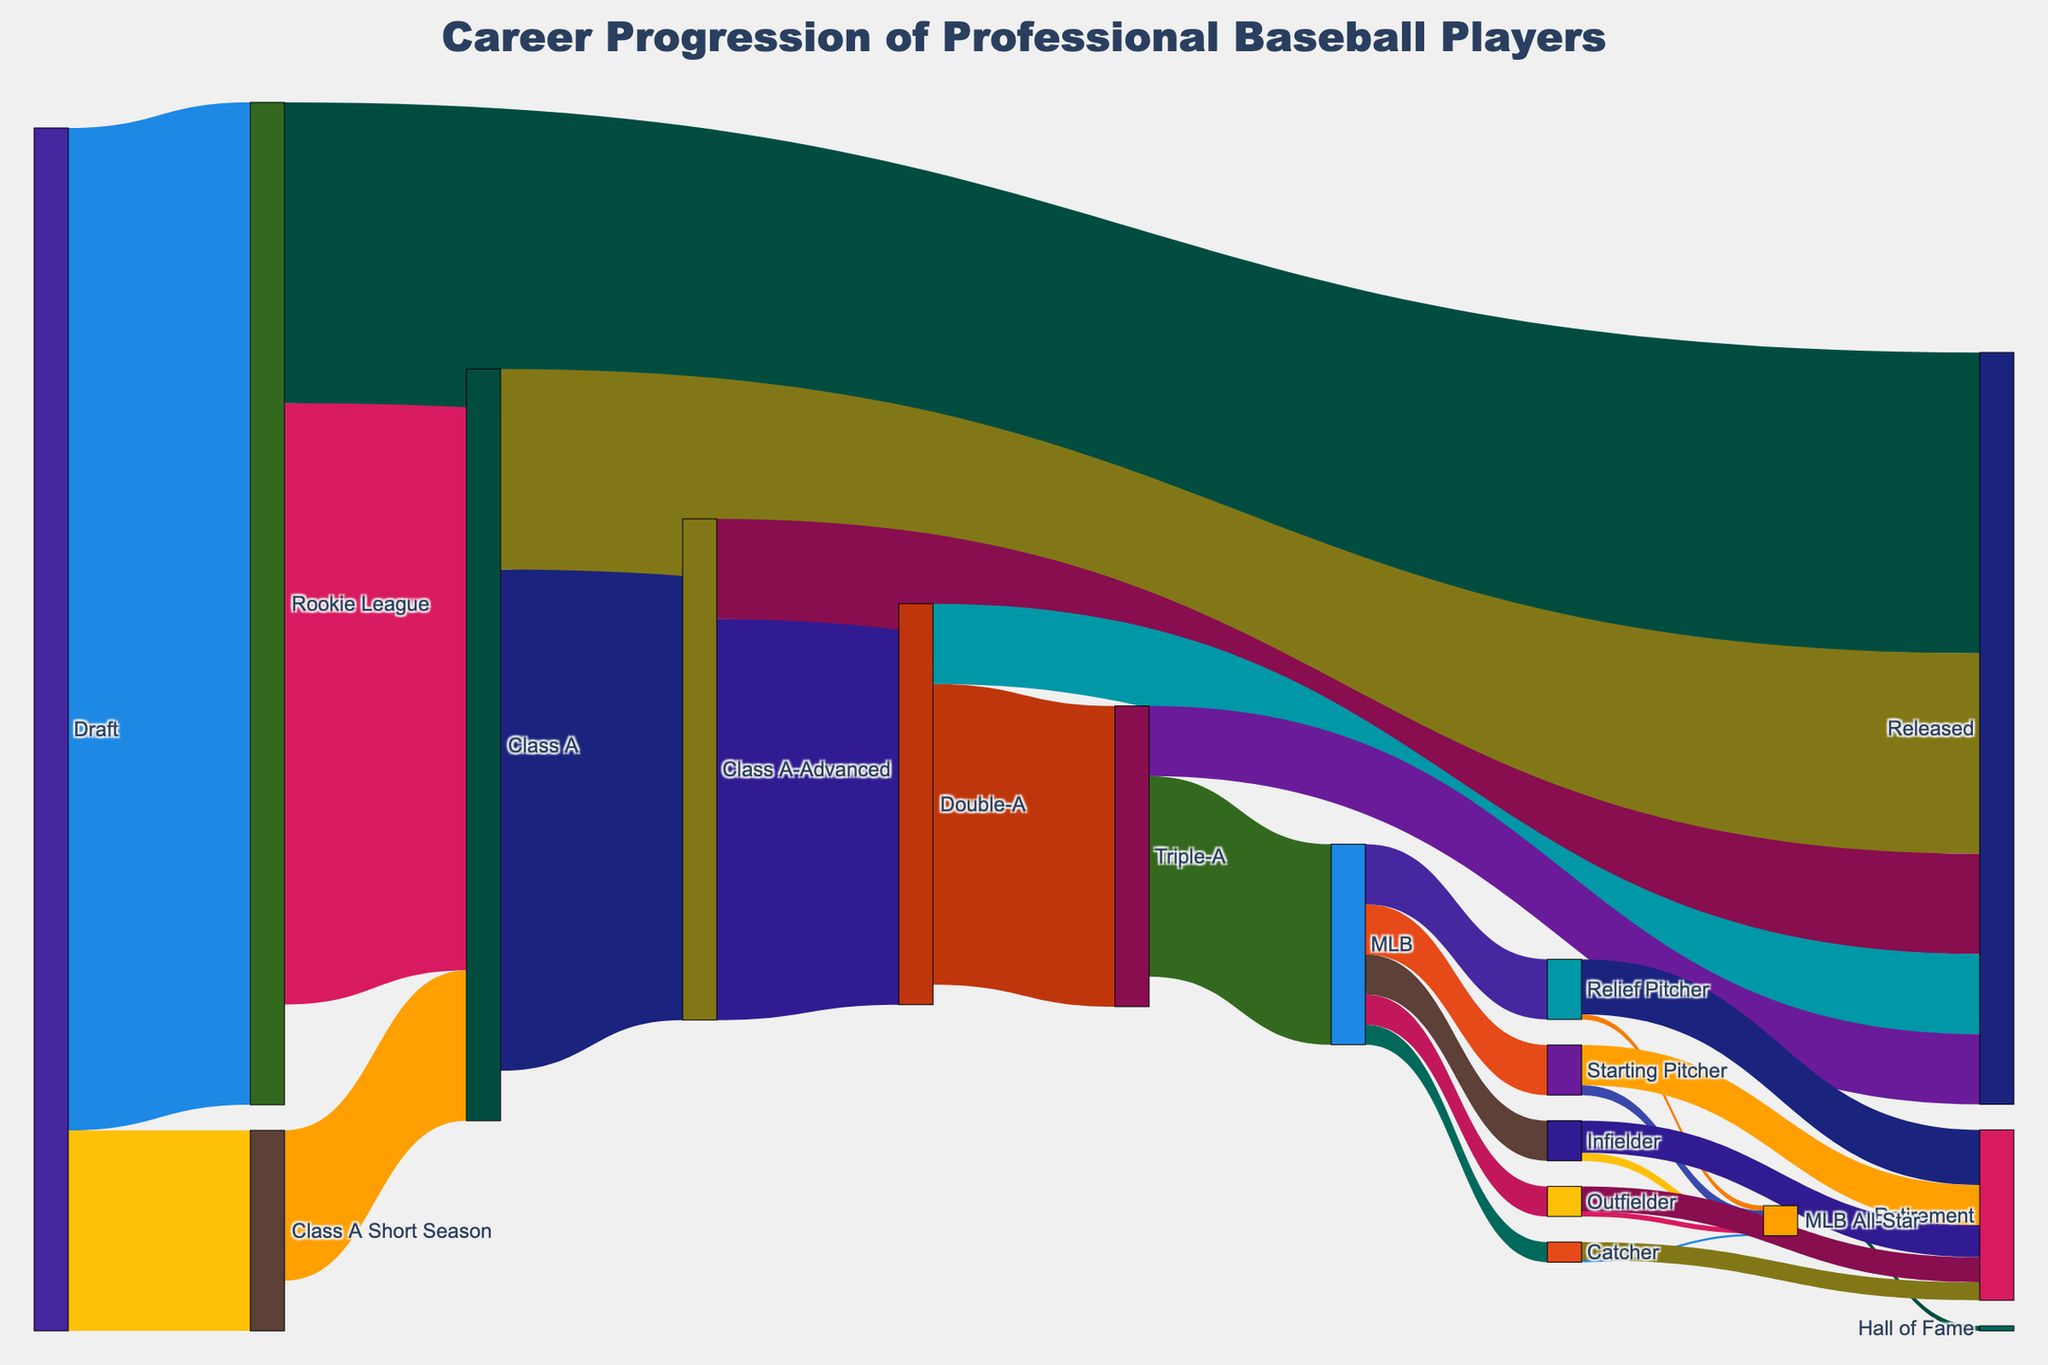How many players were drafted initially? To find the total number of players drafted, look at all the outgoing flows from the "Draft" node. Add the values: 1000 (to Rookie League) + 200 (to Class A Short Season) = 1200
Answer: 1200 What position had the least number of players reaching MLB All-Star status? Count the flows into the "MLB All-Star" node to see: Starting Pitcher (10), Relief Pitcher (5), Catcher (2), Infielder (8), Outfielder (5). Catcher has the least with 2 players
Answer: Catcher Which league level had the highest number of releases? Observe the flows directed to "Released" from each league level. Rookie League (300), Class A (200), Class A-Advanced (100), Double-A (80), Triple-A (70). Rookie League has the highest with 300
Answer: Rookie League How many players transitioned from Double-A to Triple-A? Look at the flow from "Double-A" to "Triple-A", which shows the value as 300
Answer: 300 What happens to most players after reaching Class A? Observe the outgoing flows from "Class A": Class A-Advanced (500), Released (200). Most players move to Class A-Advanced with 500
Answer: Class A-Advanced Compare the number of players who became Starting Pitchers to those who became Outfielders at the MLB level. Which position had more players? Check the flows from "MLB" to specific positions: Starting Pitcher (50), Outfielder (30). Starting Pitcher has more with 50
Answer: Starting Pitcher How many players make it from Rookie League to Class A but do not get released? Find the flow from "Rookie League" to "Class A" (600). Subtract the flow from "Rookie League" to "Released" (300): 600 - 300 = 300
Answer: 300 What proportion of players who start in Triple-A make it to the MLB? Look at the flow from "Triple-A" to "MLB" and the total outflow from "Triple-A": Triple-A to MLB (200) / (Triple-A to MLB (200) + Triple-A to Released (70)) = 200 / 270 = 0.74
Answer: 74% How many players end up retiring from the MLB level? Sum the retirement flows: Starting Pitcher (40), Relief Pitcher (55), Catcher (18), Infielder (32), Outfielder (25). Total = 40 + 55 + 18 + 32 + 25 = 170
Answer: 170 